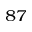Convert formula to latex. <formula><loc_0><loc_0><loc_500><loc_500>^ { 8 7 }</formula> 